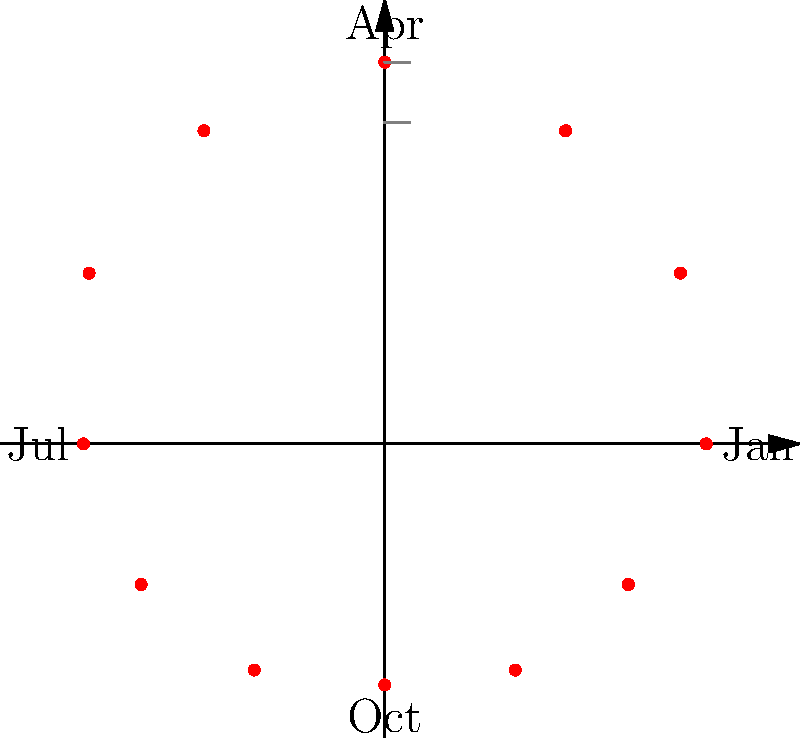As a social worker overseeing a homeless shelter program, you're analyzing seasonal fluctuations in occupancy. The polar graph shows monthly shelter occupancy rates, with distance from the center representing occupancy percentage and each month progressing clockwise. What trend does this visualization reveal about shelter usage throughout the year? To interpret the polar graph and identify the trend in shelter usage:

1. Understand the graph structure:
   - Each point represents a month, starting with January at 0° and progressing clockwise.
   - Distance from the center indicates occupancy rate (higher = more occupants).

2. Analyze the pattern:
   - January (3 o'clock position): Moderate occupancy
   - Moving clockwise, occupancy increases towards April (12 o'clock)
   - Highest occupancy is around April-May (top of the graph)
   - Occupancy decreases moving towards July (9 o'clock)
   - Lowest occupancy is around October (6 o'clock)
   - Occupancy starts increasing again towards January

3. Interpret the seasonal pattern:
   - Higher occupancy in spring (around April-May)
   - Lower occupancy in fall (around October)
   - Moderate occupancy in winter (December-January)
   - Gradual increase from fall to spring, decrease from spring to fall

4. Conclusion:
   The trend shows a clear seasonal fluctuation with peak usage in spring, lowest in fall, and moderate in winter, suggesting weather and temperature play a significant role in shelter occupancy.
Answer: Seasonal fluctuation with peak occupancy in spring, lowest in fall, and moderate in winter. 